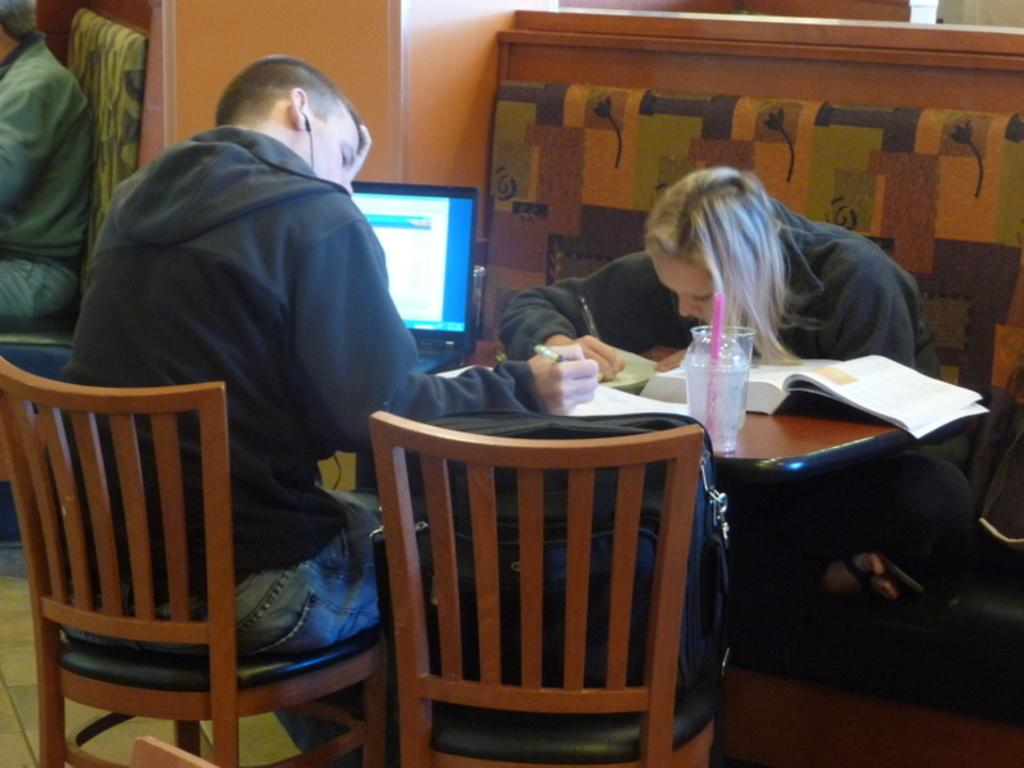How many people are in the image? There are two persons in the image. What are the persons doing in the image? The persons are sitting on chairs. How are the chairs arranged in the image? The chairs are opposite each other. What can be seen on the table in the image? There are many items on the table. What type of bell can be heard ringing in the image? There is no bell present in the image, and therefore no sound can be heard. 